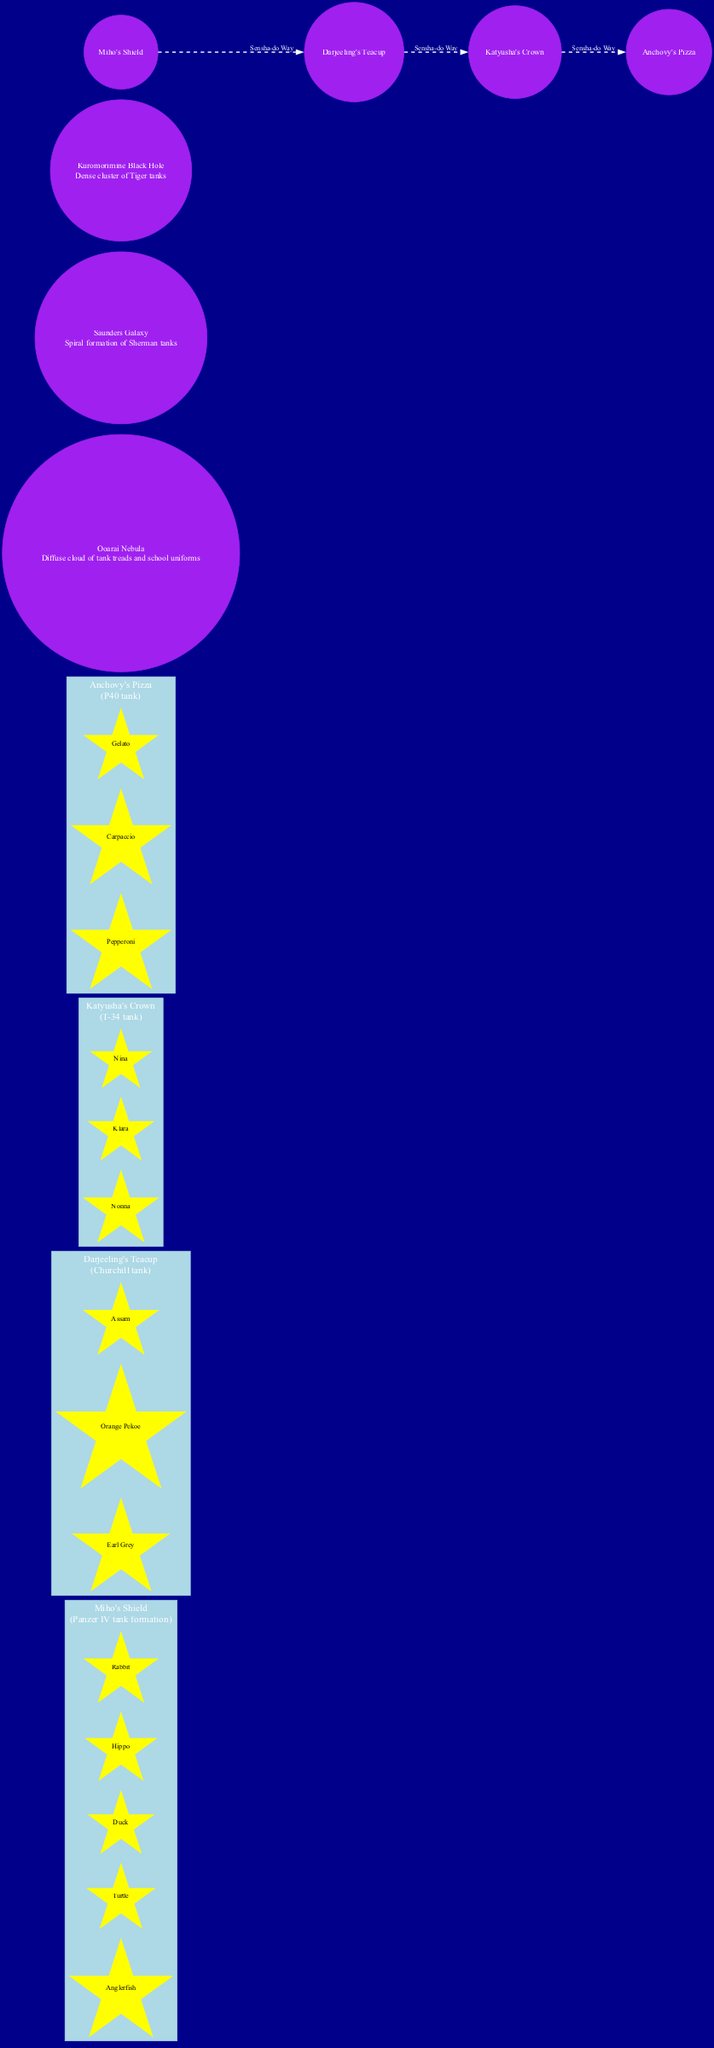What is the shape of Miho's Shield? The diagram clearly indicates that Miho's Shield is represented as a "Panzer IV tank formation." This information is found in the cluster representing Miho's Shield within the diagram.
Answer: Panzer IV tank formation How many stars are in Katyusha's Crown? The diagram lists three stars under Katyusha's Crown: Nonna, Klara, and Nina. Therefore, by counting these stars, we conclude that there are three stars in this constellation.
Answer: 3 What celestial object is described as a diffuse cloud of tank treads and school uniforms? The diagram provides a description for the Ooarai Nebula, which states it is a "Diffuse cloud of tank treads and school uniforms." Thus, it is the Ooarai Nebula that fits this description.
Answer: Ooarai Nebula Which two constellations are connected by the Sensha-do Way? The Sensha-do Way connects multiple constellations. By examining the path, we find that it directly connects Miho's Shield and Darjeeling's Teacup. So, the answer is these two constellations.
Answer: Miho's Shield and Darjeeling's Teacup What color are the nodes representing celestial objects in the diagram? In the diagram, all celestial object nodes are styled with the same attributes, which specifies that their shape is "circle" and their color is "purple." This indicates that the nodes for celestial objects are purple.
Answer: Purple What kind of galaxy is the Saunders Galaxy described as? The diagram indicates that the Saunders Galaxy has the description "Spiral formation of Sherman tanks." Therefore, based on this information, we can conclude that the Saunders Galaxy is a spiral formation.
Answer: Spiral formation How many constellations have tank shape descriptions? The diagram lists four constellations, each with a specific tank shape description. Therefore, by counting them individually, we find there are four constellations that fit this criterion.
Answer: 4 What is the connection between Anchovy's Pizza and Katyusha's Crown in the diagram? The Sensha-do Way is the path connecting Anchovy's Pizza and Katyusha's Crown. This implication is evident in the diagram as it showcases a direct link in the connecting nodes.
Answer: Sensha-do Way Which constellation features stars named Earl Grey and Assam? The constellation that includes the stars Earl Grey and Assam is labeled as "Darjeeling's Teacup" in the diagram. Therefore, this constellation contains those specific stars.
Answer: Darjeeling's Teacup 